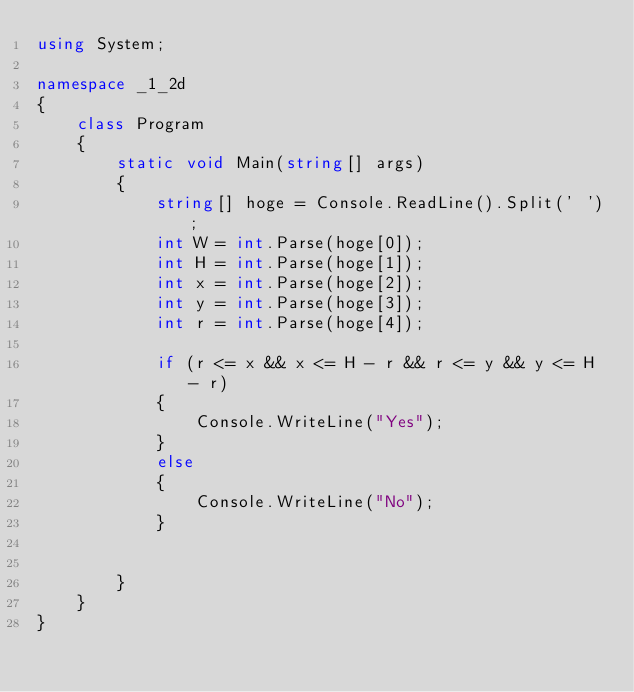<code> <loc_0><loc_0><loc_500><loc_500><_C#_>using System;

namespace _1_2d
{
    class Program
    {
        static void Main(string[] args)
        {
            string[] hoge = Console.ReadLine().Split(' ');
            int W = int.Parse(hoge[0]);
            int H = int.Parse(hoge[1]);
            int x = int.Parse(hoge[2]);
            int y = int.Parse(hoge[3]);
            int r = int.Parse(hoge[4]);

            if (r <= x && x <= H - r && r <= y && y <= H - r)
            {
                Console.WriteLine("Yes");
            }
            else
            {
                Console.WriteLine("No");
            }


        }
    }
}

</code> 